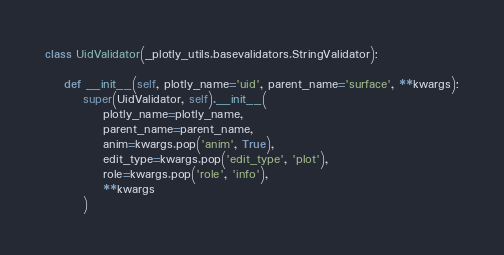Convert code to text. <code><loc_0><loc_0><loc_500><loc_500><_Python_>
class UidValidator(_plotly_utils.basevalidators.StringValidator):

    def __init__(self, plotly_name='uid', parent_name='surface', **kwargs):
        super(UidValidator, self).__init__(
            plotly_name=plotly_name,
            parent_name=parent_name,
            anim=kwargs.pop('anim', True),
            edit_type=kwargs.pop('edit_type', 'plot'),
            role=kwargs.pop('role', 'info'),
            **kwargs
        )
</code> 